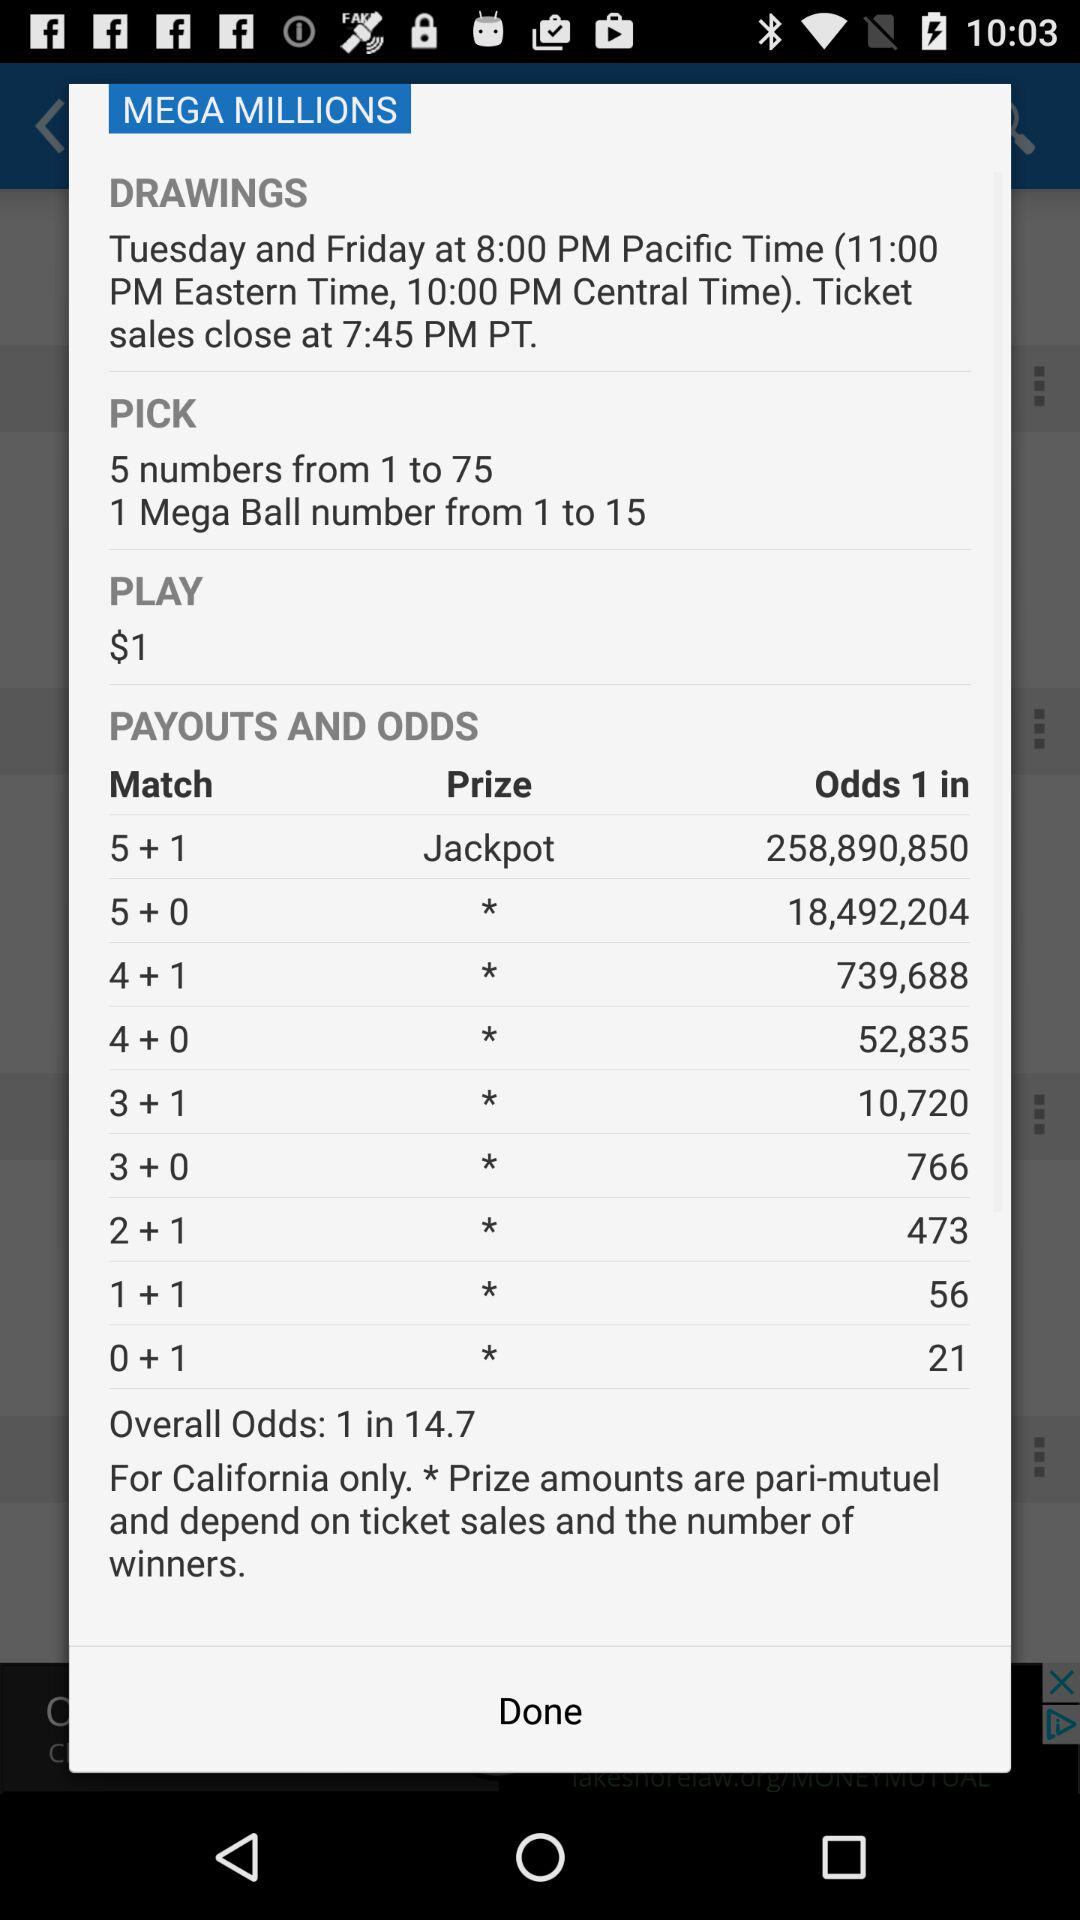What is the timing of drawings on tuesday and wednesday?
When the provided information is insufficient, respond with <no answer>. <no answer> 